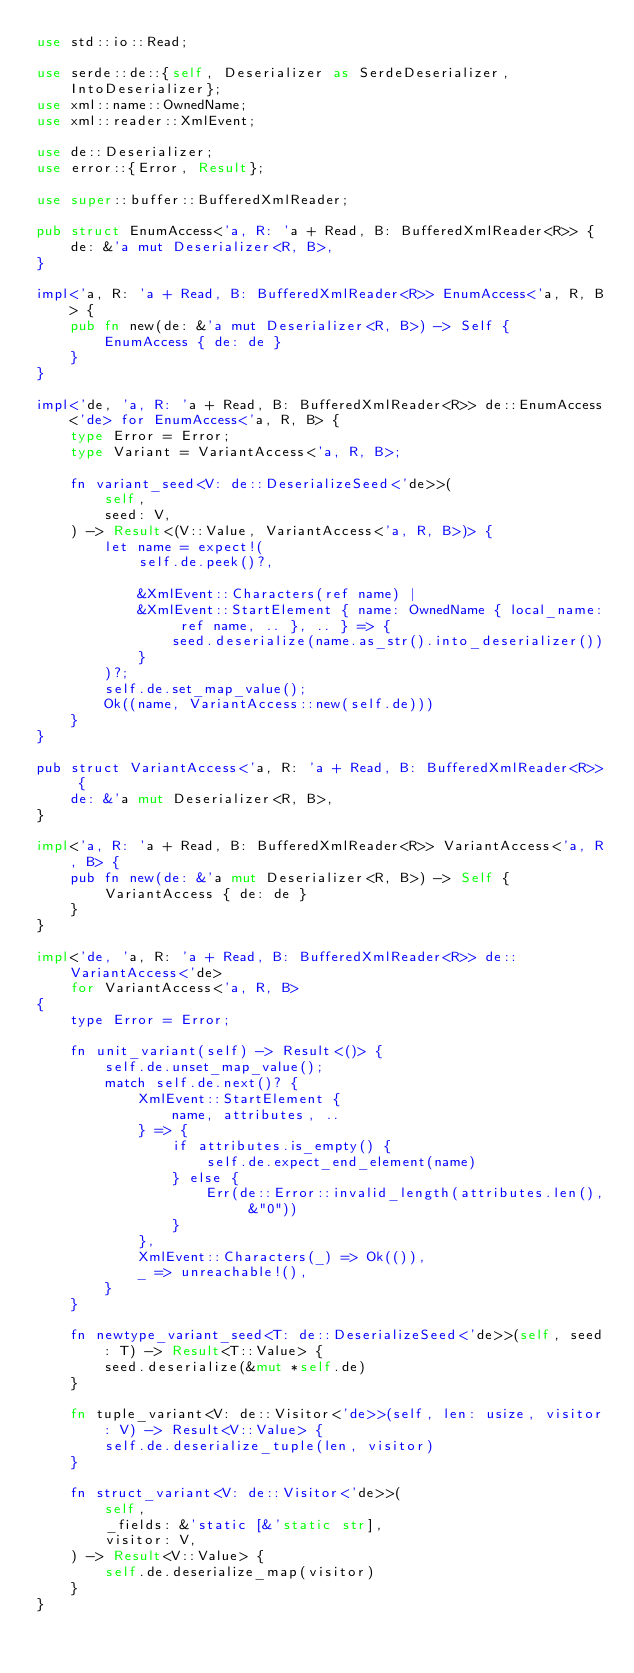Convert code to text. <code><loc_0><loc_0><loc_500><loc_500><_Rust_>use std::io::Read;

use serde::de::{self, Deserializer as SerdeDeserializer, IntoDeserializer};
use xml::name::OwnedName;
use xml::reader::XmlEvent;

use de::Deserializer;
use error::{Error, Result};

use super::buffer::BufferedXmlReader;

pub struct EnumAccess<'a, R: 'a + Read, B: BufferedXmlReader<R>> {
    de: &'a mut Deserializer<R, B>,
}

impl<'a, R: 'a + Read, B: BufferedXmlReader<R>> EnumAccess<'a, R, B> {
    pub fn new(de: &'a mut Deserializer<R, B>) -> Self {
        EnumAccess { de: de }
    }
}

impl<'de, 'a, R: 'a + Read, B: BufferedXmlReader<R>> de::EnumAccess<'de> for EnumAccess<'a, R, B> {
    type Error = Error;
    type Variant = VariantAccess<'a, R, B>;

    fn variant_seed<V: de::DeserializeSeed<'de>>(
        self,
        seed: V,
    ) -> Result<(V::Value, VariantAccess<'a, R, B>)> {
        let name = expect!(
            self.de.peek()?,

            &XmlEvent::Characters(ref name) |
            &XmlEvent::StartElement { name: OwnedName { local_name: ref name, .. }, .. } => {
                seed.deserialize(name.as_str().into_deserializer())
            }
        )?;
        self.de.set_map_value();
        Ok((name, VariantAccess::new(self.de)))
    }
}

pub struct VariantAccess<'a, R: 'a + Read, B: BufferedXmlReader<R>> {
    de: &'a mut Deserializer<R, B>,
}

impl<'a, R: 'a + Read, B: BufferedXmlReader<R>> VariantAccess<'a, R, B> {
    pub fn new(de: &'a mut Deserializer<R, B>) -> Self {
        VariantAccess { de: de }
    }
}

impl<'de, 'a, R: 'a + Read, B: BufferedXmlReader<R>> de::VariantAccess<'de>
    for VariantAccess<'a, R, B>
{
    type Error = Error;

    fn unit_variant(self) -> Result<()> {
        self.de.unset_map_value();
        match self.de.next()? {
            XmlEvent::StartElement {
                name, attributes, ..
            } => {
                if attributes.is_empty() {
                    self.de.expect_end_element(name)
                } else {
                    Err(de::Error::invalid_length(attributes.len(), &"0"))
                }
            },
            XmlEvent::Characters(_) => Ok(()),
            _ => unreachable!(),
        }
    }

    fn newtype_variant_seed<T: de::DeserializeSeed<'de>>(self, seed: T) -> Result<T::Value> {
        seed.deserialize(&mut *self.de)
    }

    fn tuple_variant<V: de::Visitor<'de>>(self, len: usize, visitor: V) -> Result<V::Value> {
        self.de.deserialize_tuple(len, visitor)
    }

    fn struct_variant<V: de::Visitor<'de>>(
        self,
        _fields: &'static [&'static str],
        visitor: V,
    ) -> Result<V::Value> {
        self.de.deserialize_map(visitor)
    }
}
</code> 